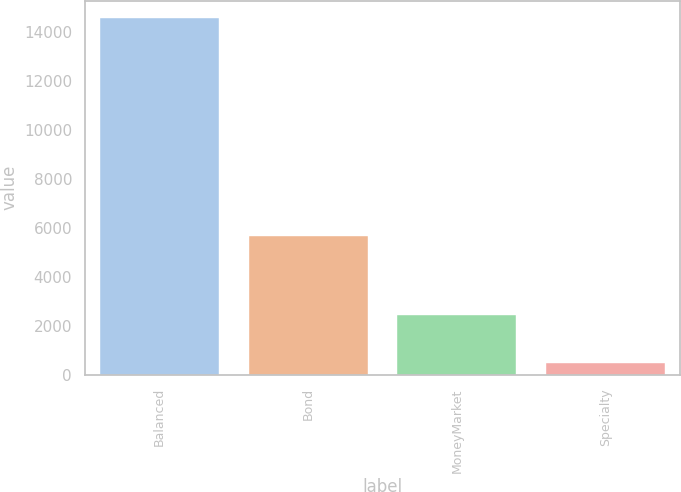<chart> <loc_0><loc_0><loc_500><loc_500><bar_chart><fcel>Balanced<fcel>Bond<fcel>MoneyMarket<fcel>Specialty<nl><fcel>14548<fcel>5671<fcel>2456<fcel>488<nl></chart> 